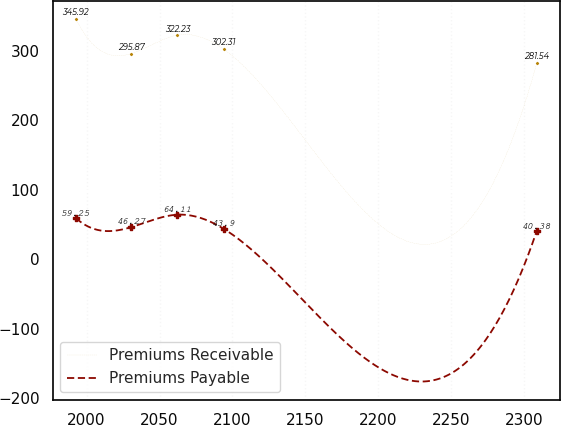<chart> <loc_0><loc_0><loc_500><loc_500><line_chart><ecel><fcel>Premiums Receivable<fcel>Premiums Payable<nl><fcel>1992.62<fcel>345.92<fcel>59.25<nl><fcel>2030.7<fcel>295.87<fcel>46.27<nl><fcel>2062.3<fcel>322.23<fcel>64.11<nl><fcel>2093.9<fcel>302.31<fcel>43.9<nl><fcel>2308.6<fcel>281.54<fcel>40.38<nl></chart> 